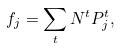<formula> <loc_0><loc_0><loc_500><loc_500>f _ { j } = \sum _ { t } N ^ { t } P ^ { t } _ { j } ,</formula> 